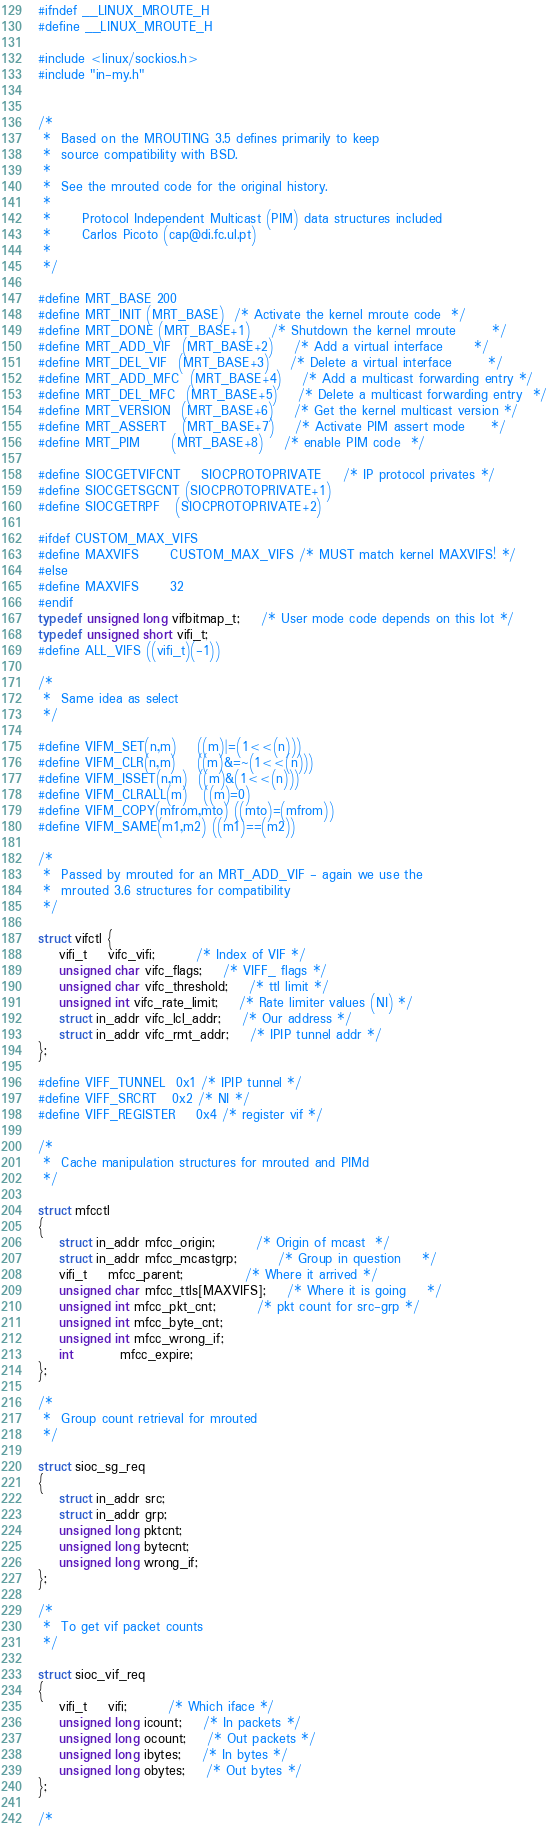<code> <loc_0><loc_0><loc_500><loc_500><_C_>#ifndef __LINUX_MROUTE_H
#define __LINUX_MROUTE_H

#include <linux/sockios.h>
#include "in-my.h"


/*
 *	Based on the MROUTING 3.5 defines primarily to keep
 *	source compatibility with BSD.
 *
 *	See the mrouted code for the original history.
 *
 *      Protocol Independent Multicast (PIM) data structures included
 *      Carlos Picoto (cap@di.fc.ul.pt)
 *
 */

#define MRT_BASE	200
#define MRT_INIT	(MRT_BASE)	/* Activate the kernel mroute code 	*/
#define MRT_DONE	(MRT_BASE+1)	/* Shutdown the kernel mroute		*/
#define MRT_ADD_VIF	(MRT_BASE+2)	/* Add a virtual interface		*/
#define MRT_DEL_VIF	(MRT_BASE+3)	/* Delete a virtual interface		*/
#define MRT_ADD_MFC	(MRT_BASE+4)	/* Add a multicast forwarding entry	*/
#define MRT_DEL_MFC	(MRT_BASE+5)	/* Delete a multicast forwarding entry	*/
#define MRT_VERSION	(MRT_BASE+6)	/* Get the kernel multicast version	*/
#define MRT_ASSERT	(MRT_BASE+7)	/* Activate PIM assert mode		*/
#define MRT_PIM		(MRT_BASE+8)	/* enable PIM code	*/

#define SIOCGETVIFCNT	SIOCPROTOPRIVATE	/* IP protocol privates */
#define SIOCGETSGCNT	(SIOCPROTOPRIVATE+1)
#define SIOCGETRPF	(SIOCPROTOPRIVATE+2)

#ifdef CUSTOM_MAX_VIFS
#define MAXVIFS		CUSTOM_MAX_VIFS /* MUST match kernel MAXVIFS! */
#else
#define MAXVIFS		32	
#endif
typedef unsigned long vifbitmap_t;	/* User mode code depends on this lot */
typedef unsigned short vifi_t;
#define ALL_VIFS	((vifi_t)(-1))

/*
 *	Same idea as select
 */
 
#define VIFM_SET(n,m)	((m)|=(1<<(n)))
#define VIFM_CLR(n,m)	((m)&=~(1<<(n)))
#define VIFM_ISSET(n,m)	((m)&(1<<(n)))
#define VIFM_CLRALL(m)	((m)=0)
#define VIFM_COPY(mfrom,mto)	((mto)=(mfrom))
#define VIFM_SAME(m1,m2)	((m1)==(m2))

/*
 *	Passed by mrouted for an MRT_ADD_VIF - again we use the
 *	mrouted 3.6 structures for compatibility
 */
 
struct vifctl {
	vifi_t	vifc_vifi;		/* Index of VIF */
	unsigned char vifc_flags;	/* VIFF_ flags */
	unsigned char vifc_threshold;	/* ttl limit */
	unsigned int vifc_rate_limit;	/* Rate limiter values (NI) */
	struct in_addr vifc_lcl_addr;	/* Our address */
	struct in_addr vifc_rmt_addr;	/* IPIP tunnel addr */
};

#define VIFF_TUNNEL	0x1	/* IPIP tunnel */
#define VIFF_SRCRT	0x2	/* NI */
#define VIFF_REGISTER	0x4	/* register vif	*/

/*
 *	Cache manipulation structures for mrouted and PIMd
 */
 
struct mfcctl
{
	struct in_addr mfcc_origin;		/* Origin of mcast	*/
	struct in_addr mfcc_mcastgrp;		/* Group in question	*/
	vifi_t	mfcc_parent;			/* Where it arrived	*/
	unsigned char mfcc_ttls[MAXVIFS];	/* Where it is going	*/
	unsigned int mfcc_pkt_cnt;		/* pkt count for src-grp */
	unsigned int mfcc_byte_cnt;
	unsigned int mfcc_wrong_if;
	int	     mfcc_expire;
};

/* 
 *	Group count retrieval for mrouted
 */
 
struct sioc_sg_req
{
	struct in_addr src;
	struct in_addr grp;
	unsigned long pktcnt;
	unsigned long bytecnt;
	unsigned long wrong_if;
};

/*
 *	To get vif packet counts
 */

struct sioc_vif_req
{
	vifi_t	vifi;		/* Which iface */
	unsigned long icount;	/* In packets */
	unsigned long ocount;	/* Out packets */
	unsigned long ibytes;	/* In bytes */
	unsigned long obytes;	/* Out bytes */
};

/*</code> 